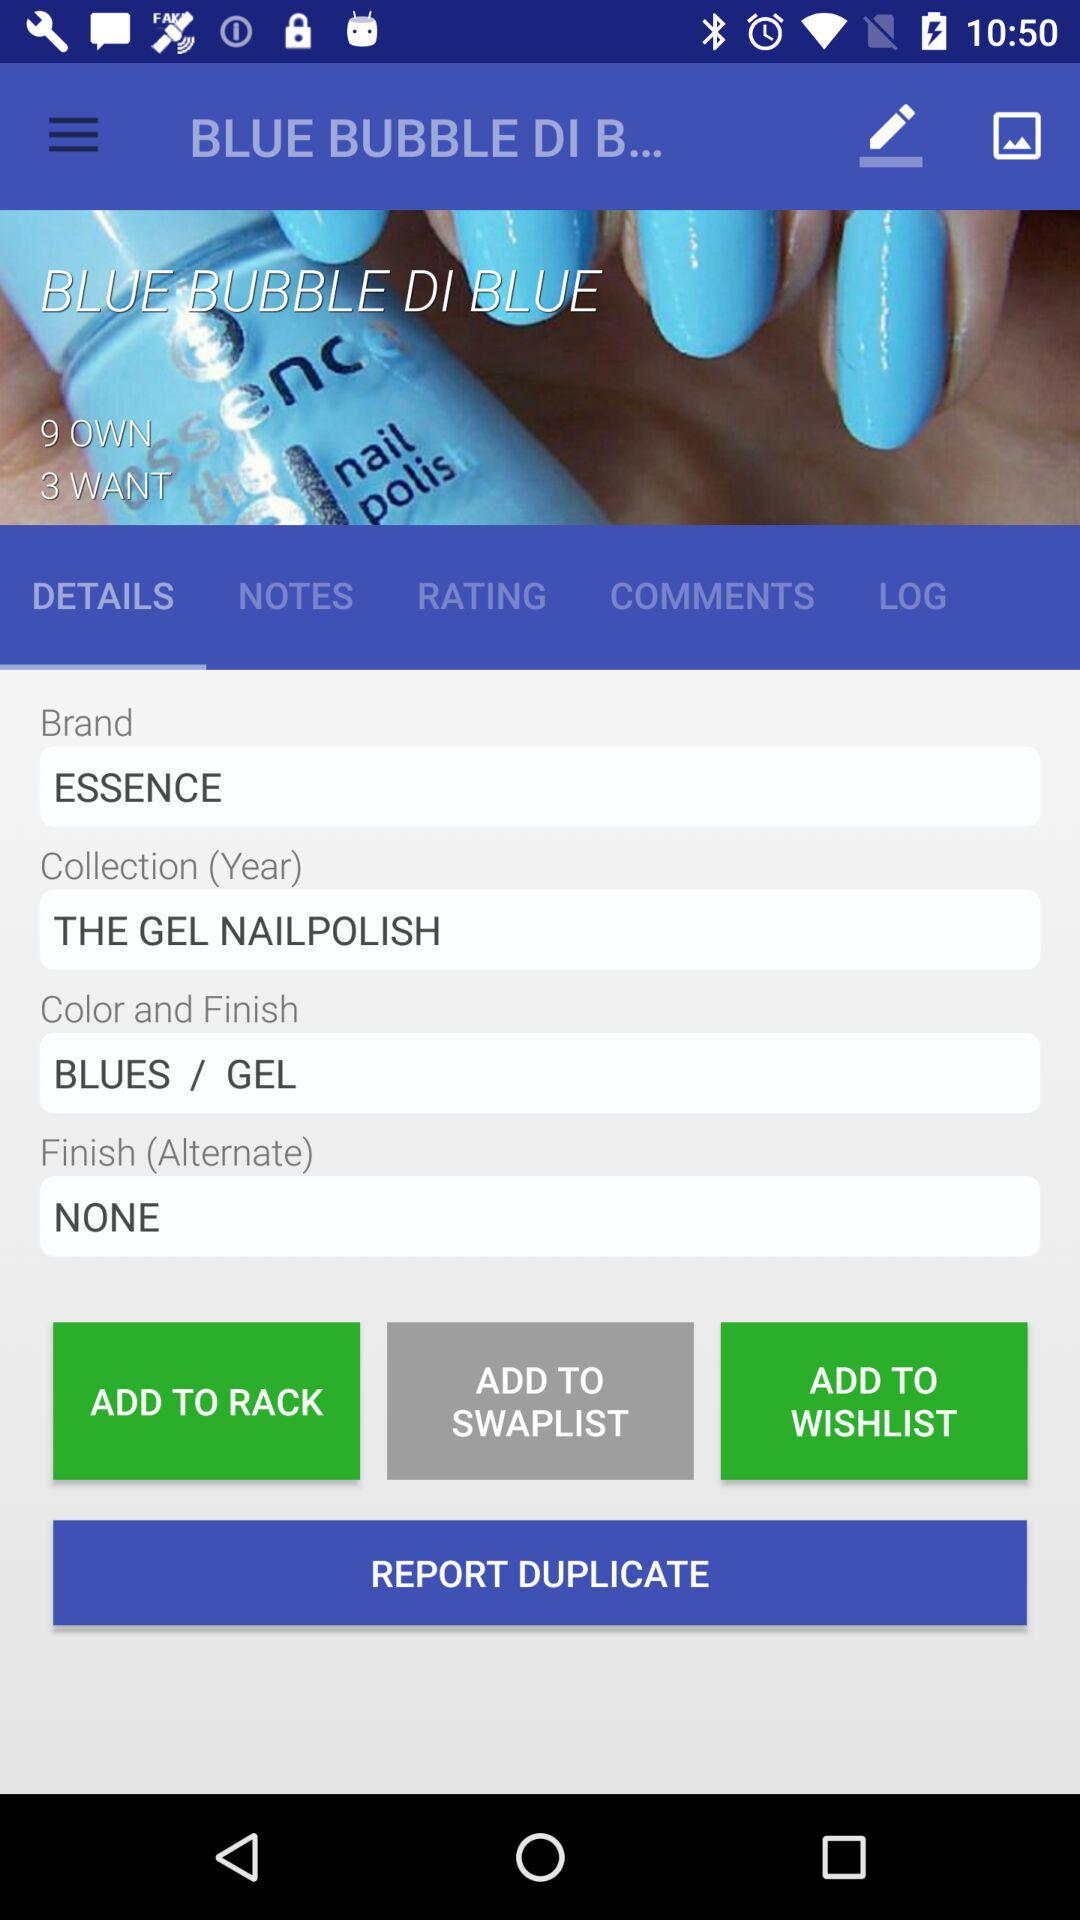What is the brand name? The brand name is "ESSENCE". 